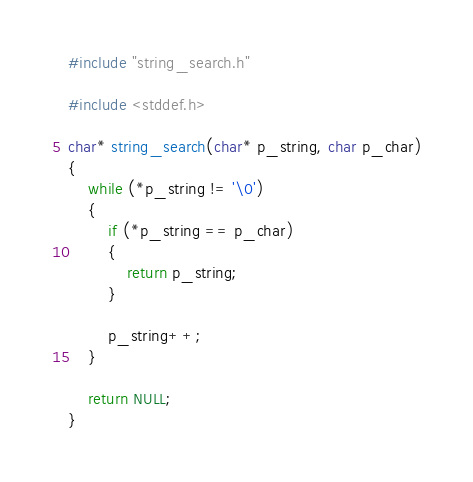<code> <loc_0><loc_0><loc_500><loc_500><_C_>#include "string_search.h"

#include <stddef.h>

char* string_search(char* p_string, char p_char)
{
	while (*p_string != '\0')
	{
		if (*p_string == p_char)
		{
			return p_string;
		}

		p_string++;
	}

	return NULL;
}
</code> 